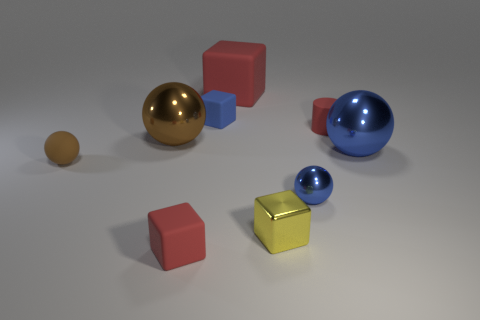There is a brown thing in front of the big blue sphere; does it have the same shape as the metal thing left of the yellow block?
Your answer should be compact. Yes. How many other things are the same size as the matte cylinder?
Provide a succinct answer. 5. How big is the brown metallic ball?
Provide a succinct answer. Large. Does the small red thing in front of the large blue object have the same material as the big red block?
Provide a succinct answer. Yes. What color is the matte thing that is the same shape as the tiny blue metal object?
Your answer should be compact. Brown. There is a shiny object to the left of the metallic block; is its color the same as the tiny matte sphere?
Offer a very short reply. Yes. There is a yellow shiny object; are there any red cubes behind it?
Make the answer very short. Yes. What color is the object that is both on the left side of the tiny yellow metallic cube and right of the small blue matte thing?
Offer a very short reply. Red. The metallic object that is the same color as the rubber sphere is what shape?
Provide a short and direct response. Sphere. What is the size of the blue thing behind the big shiny ball that is on the right side of the large brown metal thing?
Your answer should be compact. Small. 